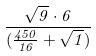<formula> <loc_0><loc_0><loc_500><loc_500>\frac { \sqrt { 9 } \cdot 6 } { ( \frac { 4 5 0 } { 1 6 } + \sqrt { 1 } ) }</formula> 